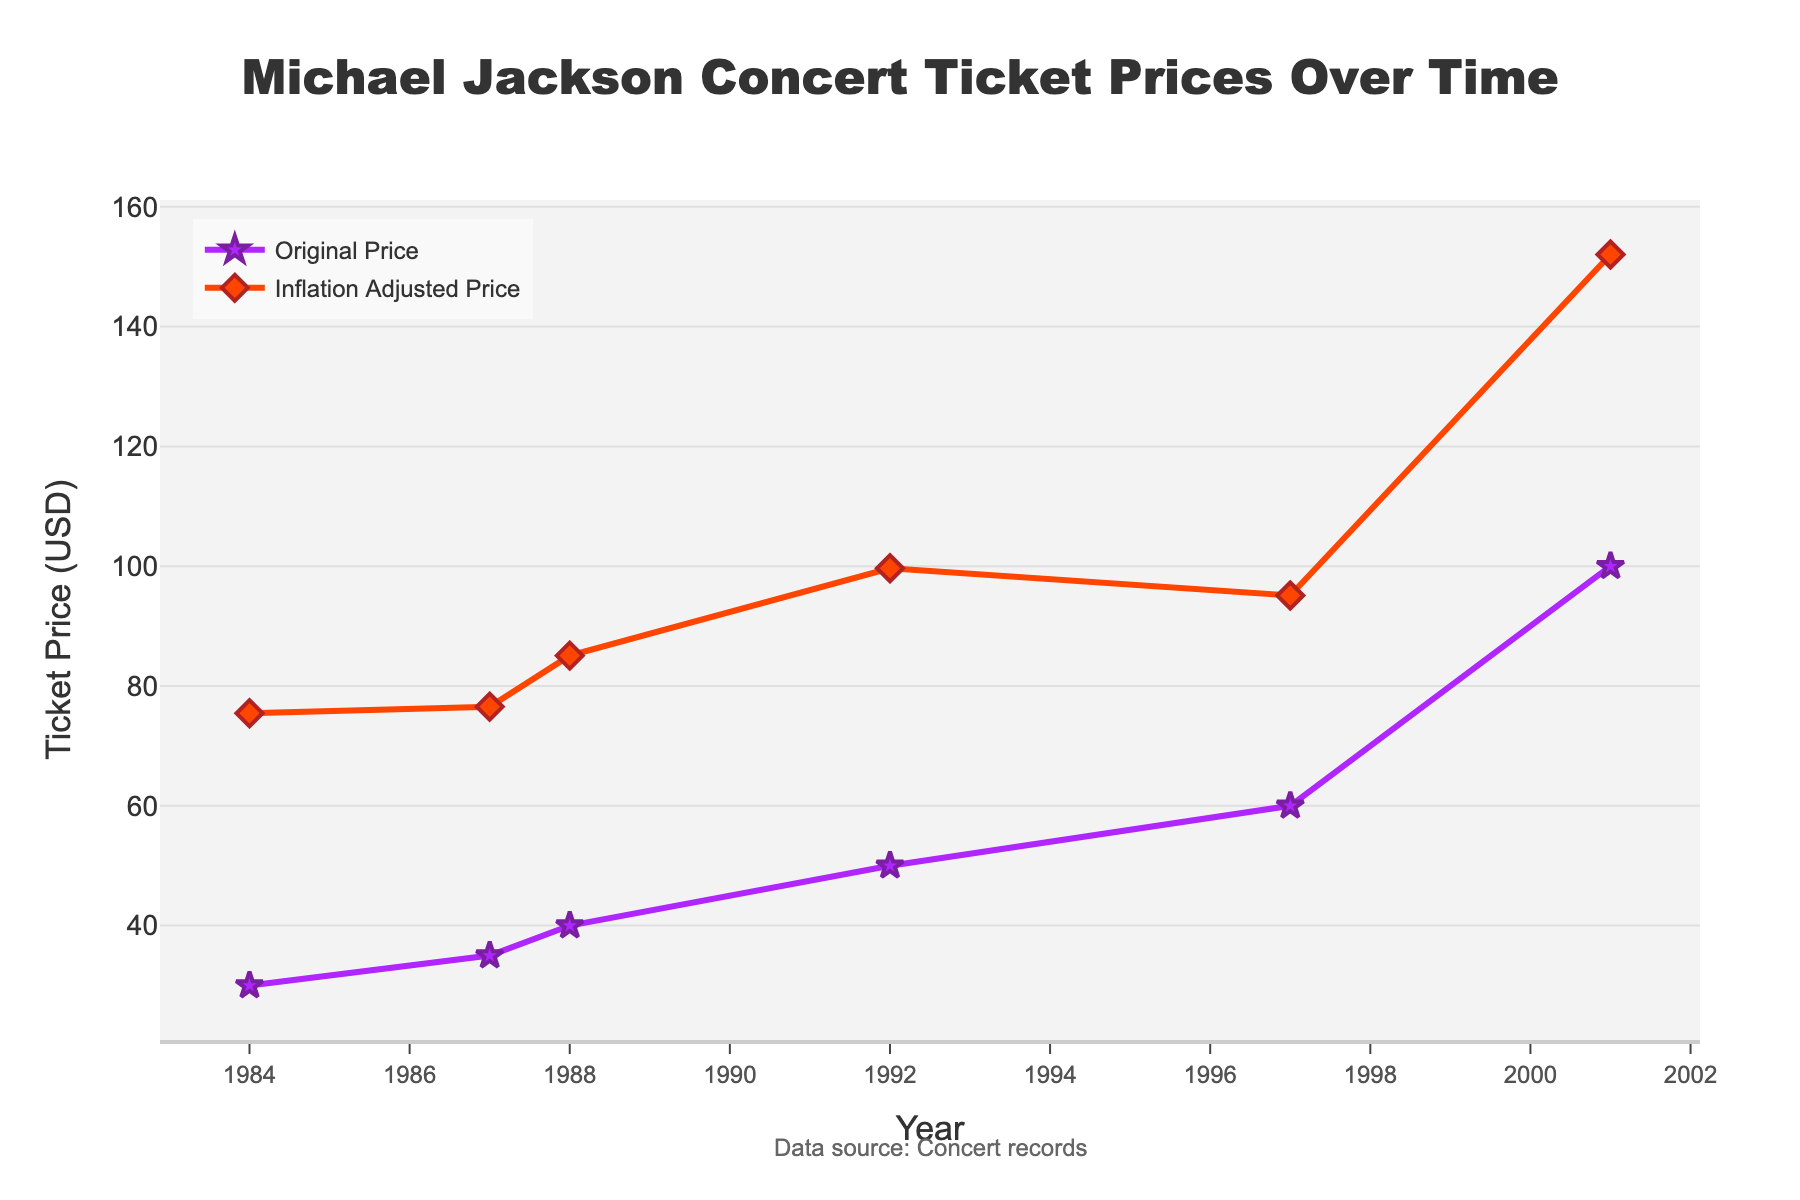what's the title of the figure? The title is prominently displayed at the top of the figure in a large font and is centered.
Answer: Michael Jackson Concert Ticket Prices Over Time How many years are depicted in the plot? By counting the unique year labels along the x-axis, we can see that there are six years.
Answer: 6 What is the ticket price for the 'Bad Tour' in 1987 after adjusting for inflation? From the chart, locate the point for 1987 and follow the inflation-adjusted (orange, diamond symbols) line to see the corresponding value.
Answer: $76.54 What is the price difference between the original and inflation-adjusted ticket prices for the 30th Anniversary Special? Find the two points for the year 2001 and subtract the original price from the inflation-adjusted price: $152.04 - $100
Answer: $52.04 Which concert tour had the highest inflation-adjusted ticket price? Look for the peak value on the inflation-adjusted price line (orange, diamond symbols). The highest point corresponds to the 30th Anniversary Special in 2001.
Answer: 30th Anniversary Special How did the original ticket price change from the 'Victory Tour' in 1984 to the 'HIStory Tour' in 1997? Find the two points in 1984 and 1997 on the original price (purple, star symbols) line and calculate the difference: $60 - $30
Answer: Increased by $30 Between which two consecutive concerts did the inflation-adjusted price see the largest increase? Compare the year-to-year changes in the inflation-adjusted line (orange, diamond symbols) and identify the largest difference. The biggest jump is between the HIStory Tour in 1997 and the 30th Anniversary Special in 2001.
Answer: HIStory Tour to 30th Anniversary Special What general trend is observed in the inflation-adjusted ticket prices over the time covered in the plot? Observe the overall direction of the inflation-adjusted price line. Despite some fluctuations, there is a generally increasing trend from 1984 to 2001.
Answer: Generally increasing In which year was the difference between the original and inflation-adjusted ticket prices the smallest? Compare the distances between the two lines for each year. The smallest gap is in 1987 for the 'Bad Tour'.
Answer: 1987 